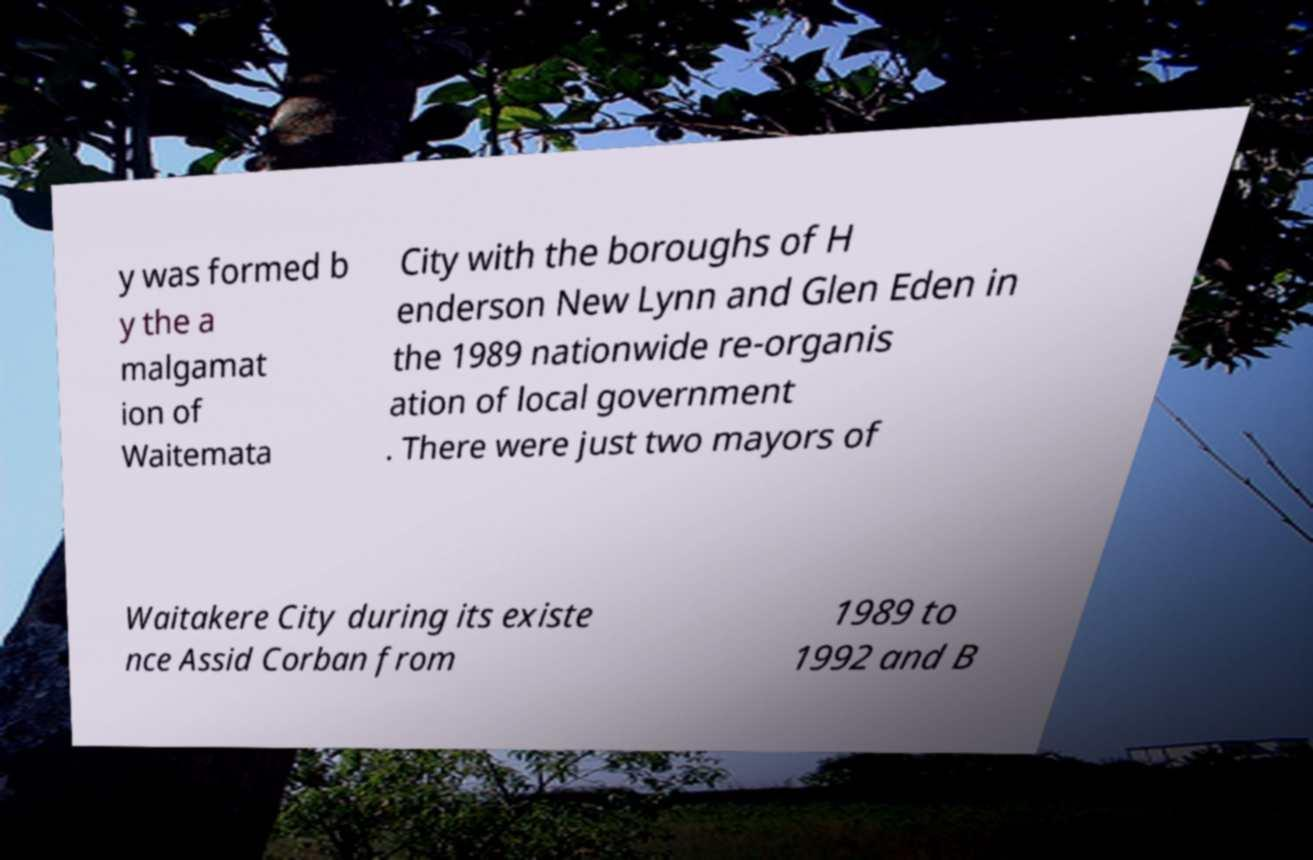I need the written content from this picture converted into text. Can you do that? y was formed b y the a malgamat ion of Waitemata City with the boroughs of H enderson New Lynn and Glen Eden in the 1989 nationwide re-organis ation of local government . There were just two mayors of Waitakere City during its existe nce Assid Corban from 1989 to 1992 and B 